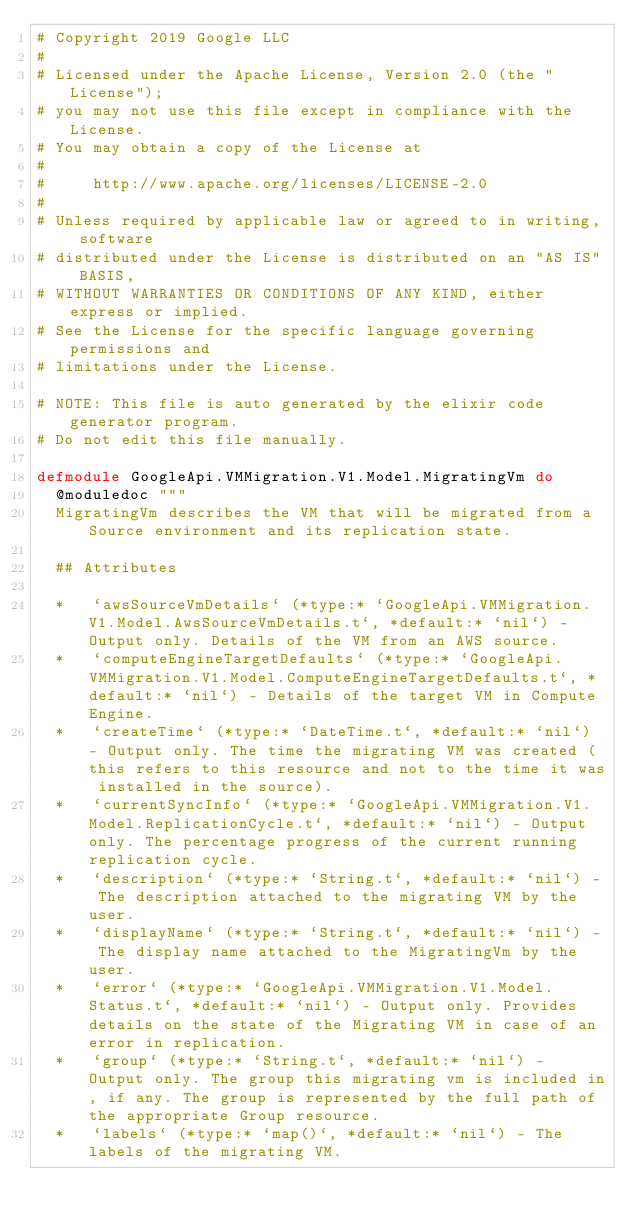Convert code to text. <code><loc_0><loc_0><loc_500><loc_500><_Elixir_># Copyright 2019 Google LLC
#
# Licensed under the Apache License, Version 2.0 (the "License");
# you may not use this file except in compliance with the License.
# You may obtain a copy of the License at
#
#     http://www.apache.org/licenses/LICENSE-2.0
#
# Unless required by applicable law or agreed to in writing, software
# distributed under the License is distributed on an "AS IS" BASIS,
# WITHOUT WARRANTIES OR CONDITIONS OF ANY KIND, either express or implied.
# See the License for the specific language governing permissions and
# limitations under the License.

# NOTE: This file is auto generated by the elixir code generator program.
# Do not edit this file manually.

defmodule GoogleApi.VMMigration.V1.Model.MigratingVm do
  @moduledoc """
  MigratingVm describes the VM that will be migrated from a Source environment and its replication state.

  ## Attributes

  *   `awsSourceVmDetails` (*type:* `GoogleApi.VMMigration.V1.Model.AwsSourceVmDetails.t`, *default:* `nil`) - Output only. Details of the VM from an AWS source.
  *   `computeEngineTargetDefaults` (*type:* `GoogleApi.VMMigration.V1.Model.ComputeEngineTargetDefaults.t`, *default:* `nil`) - Details of the target VM in Compute Engine.
  *   `createTime` (*type:* `DateTime.t`, *default:* `nil`) - Output only. The time the migrating VM was created (this refers to this resource and not to the time it was installed in the source).
  *   `currentSyncInfo` (*type:* `GoogleApi.VMMigration.V1.Model.ReplicationCycle.t`, *default:* `nil`) - Output only. The percentage progress of the current running replication cycle.
  *   `description` (*type:* `String.t`, *default:* `nil`) - The description attached to the migrating VM by the user.
  *   `displayName` (*type:* `String.t`, *default:* `nil`) - The display name attached to the MigratingVm by the user.
  *   `error` (*type:* `GoogleApi.VMMigration.V1.Model.Status.t`, *default:* `nil`) - Output only. Provides details on the state of the Migrating VM in case of an error in replication.
  *   `group` (*type:* `String.t`, *default:* `nil`) - Output only. The group this migrating vm is included in, if any. The group is represented by the full path of the appropriate Group resource.
  *   `labels` (*type:* `map()`, *default:* `nil`) - The labels of the migrating VM.</code> 